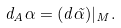<formula> <loc_0><loc_0><loc_500><loc_500>d _ { A } \alpha = ( d \tilde { \alpha } ) | _ { M } .</formula> 